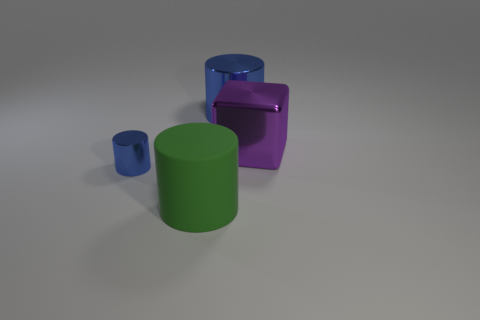What number of tiny things are either purple things or red matte cylinders?
Your answer should be compact. 0. The shiny block is what color?
Ensure brevity in your answer.  Purple. Is there a large metallic object left of the big thing behind the large purple cube?
Your response must be concise. No. Is the number of blue objects on the left side of the large matte cylinder less than the number of gray rubber things?
Offer a very short reply. No. Does the object left of the large green rubber thing have the same material as the purple cube?
Give a very brief answer. Yes. What is the color of the small object that is made of the same material as the big purple thing?
Make the answer very short. Blue. Is the number of large objects behind the large metallic block less than the number of big cubes left of the big metal cylinder?
Keep it short and to the point. No. Does the metal cylinder to the left of the rubber object have the same color as the metallic cylinder behind the tiny blue metallic cylinder?
Make the answer very short. Yes. Are there any other small blue objects that have the same material as the tiny object?
Offer a terse response. No. What size is the blue cylinder behind the large object that is on the right side of the large blue cylinder?
Keep it short and to the point. Large. 